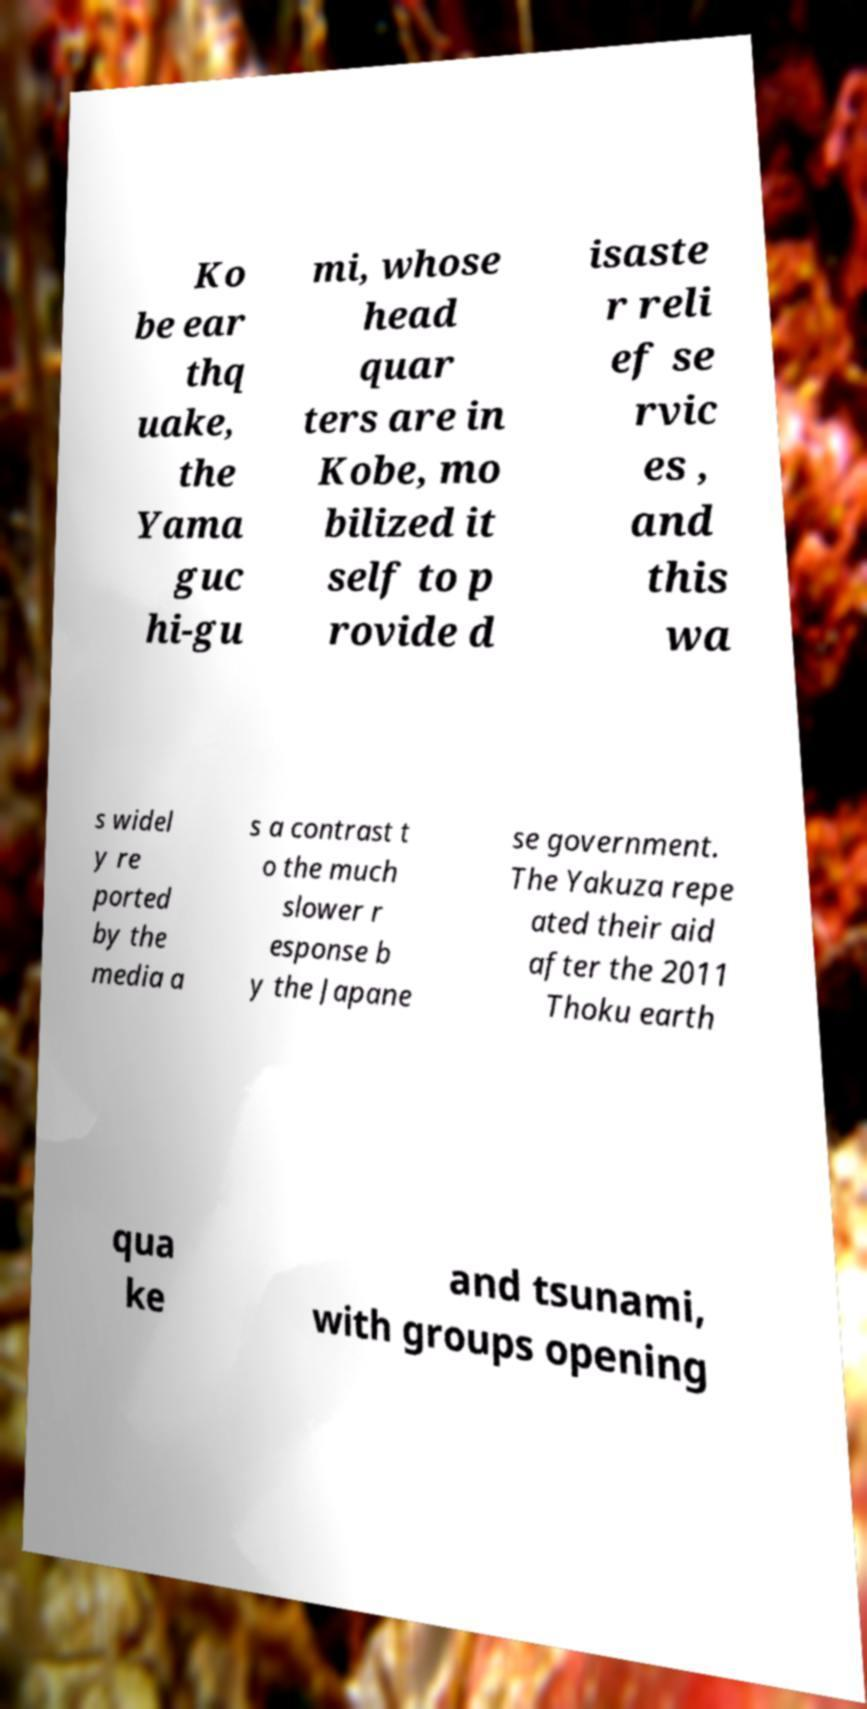Can you read and provide the text displayed in the image?This photo seems to have some interesting text. Can you extract and type it out for me? Ko be ear thq uake, the Yama guc hi-gu mi, whose head quar ters are in Kobe, mo bilized it self to p rovide d isaste r reli ef se rvic es , and this wa s widel y re ported by the media a s a contrast t o the much slower r esponse b y the Japane se government. The Yakuza repe ated their aid after the 2011 Thoku earth qua ke and tsunami, with groups opening 